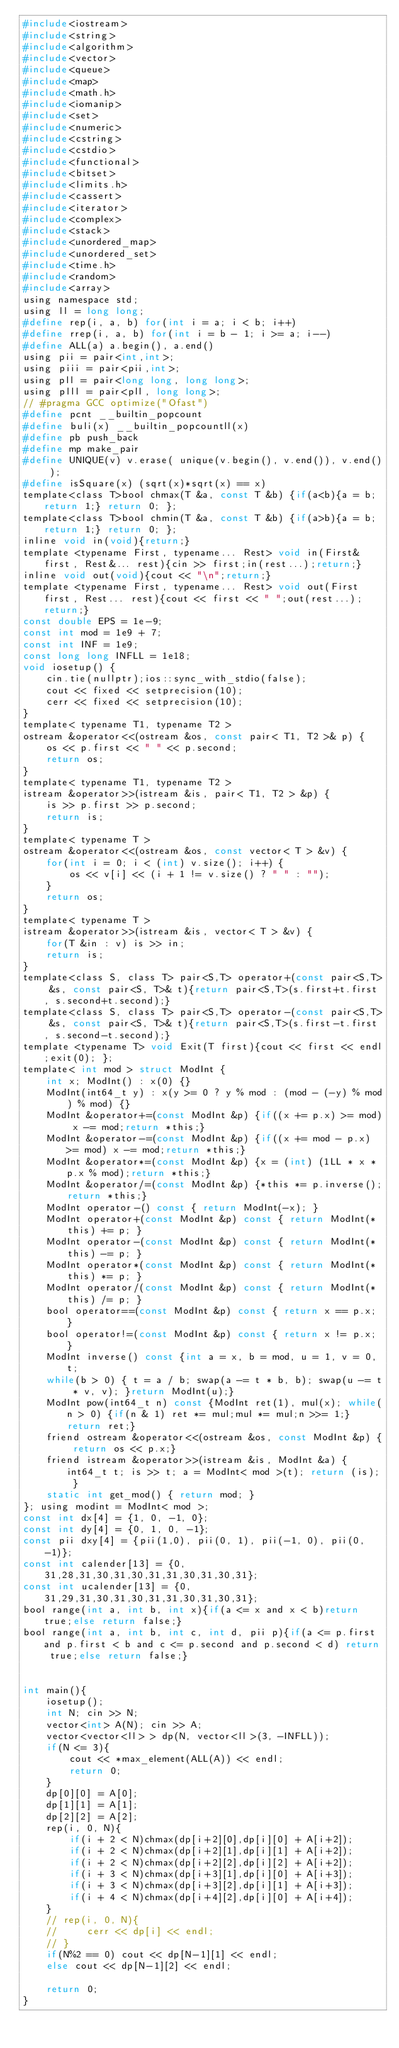Convert code to text. <code><loc_0><loc_0><loc_500><loc_500><_C_>#include<iostream>
#include<string>
#include<algorithm>
#include<vector>
#include<queue>
#include<map>
#include<math.h>
#include<iomanip>
#include<set>
#include<numeric>
#include<cstring>
#include<cstdio>
#include<functional>
#include<bitset>
#include<limits.h>
#include<cassert>
#include<iterator>
#include<complex>
#include<stack>
#include<unordered_map>
#include<unordered_set>
#include<time.h>
#include<random>
#include<array>
using namespace std;
using ll = long long;
#define rep(i, a, b) for(int i = a; i < b; i++)
#define rrep(i, a, b) for(int i = b - 1; i >= a; i--)
#define ALL(a) a.begin(), a.end()
using pii = pair<int,int>;
using piii = pair<pii,int>;
using pll = pair<long long, long long>;
using plll = pair<pll, long long>;
// #pragma GCC optimize("Ofast")
#define pcnt __builtin_popcount
#define buli(x) __builtin_popcountll(x)
#define pb push_back
#define mp make_pair
#define UNIQUE(v) v.erase( unique(v.begin(), v.end()), v.end() );
#define isSquare(x) (sqrt(x)*sqrt(x) == x)
template<class T>bool chmax(T &a, const T &b) {if(a<b){a = b; return 1;} return 0; };
template<class T>bool chmin(T &a, const T &b) {if(a>b){a = b; return 1;} return 0; };
inline void in(void){return;}
template <typename First, typename... Rest> void in(First& first, Rest&... rest){cin >> first;in(rest...);return;}
inline void out(void){cout << "\n";return;}
template <typename First, typename... Rest> void out(First first, Rest... rest){cout << first << " ";out(rest...);return;}
const double EPS = 1e-9;
const int mod = 1e9 + 7;
const int INF = 1e9;
const long long INFLL = 1e18;
void iosetup() {
    cin.tie(nullptr);ios::sync_with_stdio(false);
    cout << fixed << setprecision(10);
    cerr << fixed << setprecision(10);
}
template< typename T1, typename T2 >
ostream &operator<<(ostream &os, const pair< T1, T2 >& p) {
    os << p.first << " " << p.second;
    return os;
}
template< typename T1, typename T2 >
istream &operator>>(istream &is, pair< T1, T2 > &p) {
    is >> p.first >> p.second;
    return is;
}
template< typename T >
ostream &operator<<(ostream &os, const vector< T > &v) {
    for(int i = 0; i < (int) v.size(); i++) {
        os << v[i] << (i + 1 != v.size() ? " " : "");
    }
    return os;
}
template< typename T >
istream &operator>>(istream &is, vector< T > &v) {
    for(T &in : v) is >> in;
    return is;
}
template<class S, class T> pair<S,T> operator+(const pair<S,T> &s, const pair<S, T>& t){return pair<S,T>(s.first+t.first, s.second+t.second);}
template<class S, class T> pair<S,T> operator-(const pair<S,T> &s, const pair<S, T>& t){return pair<S,T>(s.first-t.first, s.second-t.second);}
template <typename T> void Exit(T first){cout << first << endl;exit(0); };
template< int mod > struct ModInt {
    int x; ModInt() : x(0) {}
    ModInt(int64_t y) : x(y >= 0 ? y % mod : (mod - (-y) % mod) % mod) {}
    ModInt &operator+=(const ModInt &p) {if((x += p.x) >= mod) x -= mod;return *this;}
    ModInt &operator-=(const ModInt &p) {if((x += mod - p.x) >= mod) x -= mod;return *this;}
    ModInt &operator*=(const ModInt &p) {x = (int) (1LL * x * p.x % mod);return *this;}
    ModInt &operator/=(const ModInt &p) {*this *= p.inverse();return *this;}
    ModInt operator-() const { return ModInt(-x); }
    ModInt operator+(const ModInt &p) const { return ModInt(*this) += p; }
    ModInt operator-(const ModInt &p) const { return ModInt(*this) -= p; }
    ModInt operator*(const ModInt &p) const { return ModInt(*this) *= p; }
    ModInt operator/(const ModInt &p) const { return ModInt(*this) /= p; }
    bool operator==(const ModInt &p) const { return x == p.x; }
    bool operator!=(const ModInt &p) const { return x != p.x; }
    ModInt inverse() const {int a = x, b = mod, u = 1, v = 0, t;
    while(b > 0) { t = a / b; swap(a -= t * b, b); swap(u -= t * v, v); }return ModInt(u);}
    ModInt pow(int64_t n) const {ModInt ret(1), mul(x); while(n > 0) {if(n & 1) ret *= mul;mul *= mul;n >>= 1;}return ret;}
    friend ostream &operator<<(ostream &os, const ModInt &p) { return os << p.x;}
    friend istream &operator>>(istream &is, ModInt &a) { int64_t t; is >> t; a = ModInt< mod >(t); return (is); }
    static int get_mod() { return mod; }
}; using modint = ModInt< mod >;
const int dx[4] = {1, 0, -1, 0};
const int dy[4] = {0, 1, 0, -1};
const pii dxy[4] = {pii(1,0), pii(0, 1), pii(-1, 0), pii(0, -1)};
const int calender[13] = {0, 31,28,31,30,31,30,31,31,30,31,30,31};
const int ucalender[13] = {0, 31,29,31,30,31,30,31,31,30,31,30,31};
bool range(int a, int b, int x){if(a <= x and x < b)return true;else return false;}
bool range(int a, int b, int c, int d, pii p){if(a <= p.first and p.first < b and c <= p.second and p.second < d) return true;else return false;}


int main(){
    iosetup();
    int N; cin >> N;
    vector<int> A(N); cin >> A;
    vector<vector<ll> > dp(N, vector<ll>(3, -INFLL));
    if(N <= 3){
        cout << *max_element(ALL(A)) << endl;
        return 0;
    }
    dp[0][0] = A[0];
    dp[1][1] = A[1];
    dp[2][2] = A[2];
    rep(i, 0, N){
        if(i + 2 < N)chmax(dp[i+2][0],dp[i][0] + A[i+2]);
        if(i + 2 < N)chmax(dp[i+2][1],dp[i][1] + A[i+2]);
        if(i + 2 < N)chmax(dp[i+2][2],dp[i][2] + A[i+2]);
        if(i + 3 < N)chmax(dp[i+3][1],dp[i][0] + A[i+3]);
        if(i + 3 < N)chmax(dp[i+3][2],dp[i][1] + A[i+3]);
        if(i + 4 < N)chmax(dp[i+4][2],dp[i][0] + A[i+4]);
    }
    // rep(i, 0, N){
    //     cerr << dp[i] << endl;
    // }
    if(N%2 == 0) cout << dp[N-1][1] << endl;
    else cout << dp[N-1][2] << endl;

    return 0;
}
</code> 